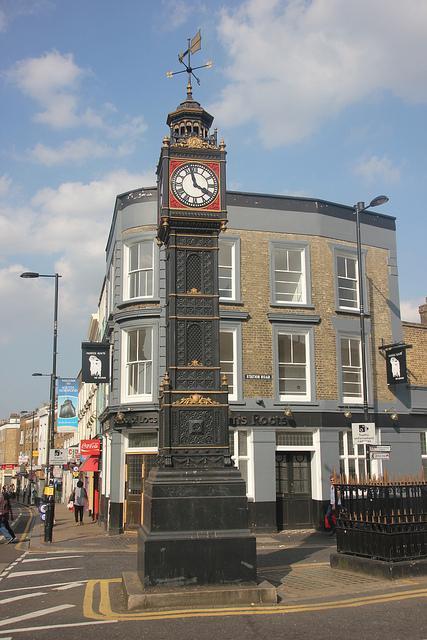How many clocks are there?
Give a very brief answer. 1. How many people are on the sidewalk?
Give a very brief answer. 1. 